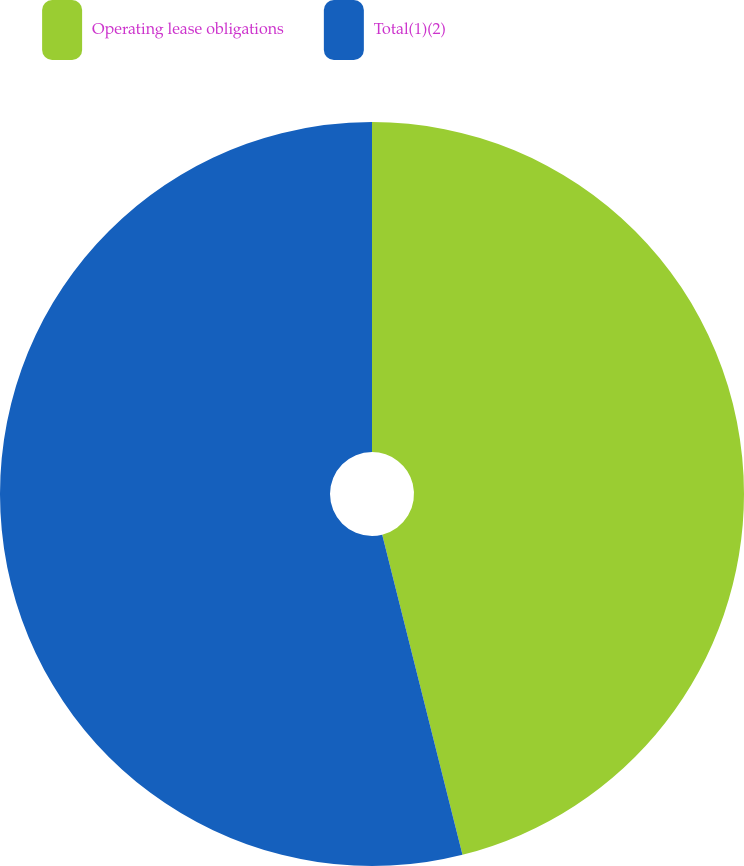Convert chart. <chart><loc_0><loc_0><loc_500><loc_500><pie_chart><fcel>Operating lease obligations<fcel>Total(1)(2)<nl><fcel>46.09%<fcel>53.91%<nl></chart> 